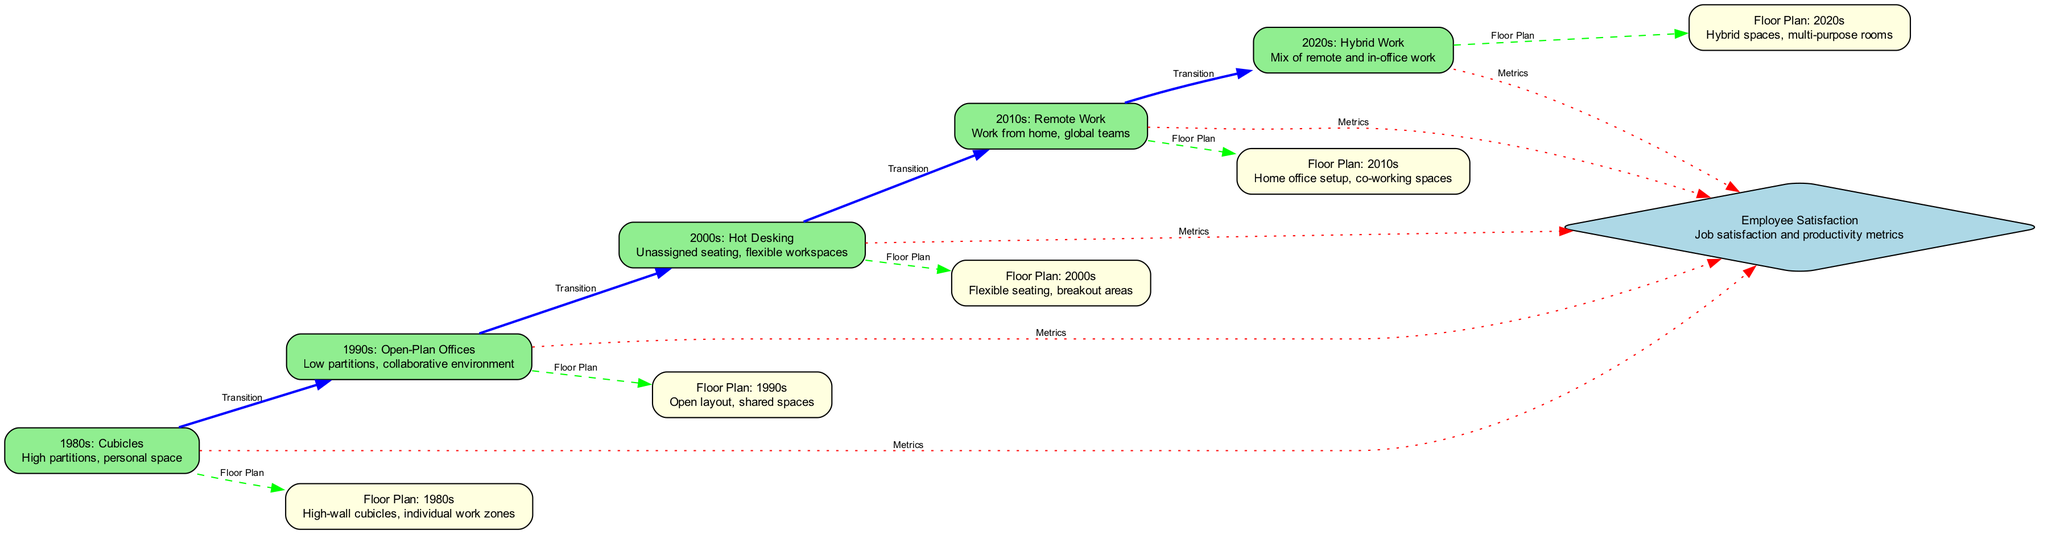What is the label of the node for the 1980s office design? The node for the 1980s office design is labeled "1980s: Cubicles". By examining the nodes in the diagram, I find the entry corresponding to "1980s" and read its associated label.
Answer: 1980s: Cubicles How many types of office designs are represented in the diagram? Counting the distinct office design nodes listed under 'nodes', I find five types: Cubicles, Open-Plan Offices, Hot Desking, Remote Work, and Hybrid Work.
Answer: Five What do the edges labeled "Transition" indicate? The edges labeled "Transition" connect various stages of office design evolution, showing the progression from one design to another. By examining the labels attached to each edge, I confirm they denote a transitional phase between different office designs.
Answer: Progression of office designs Which floor plan corresponds to the 2000s office design? The diagram indicates that the floor plan corresponding to the 2000s office design is labeled "Floor Plan: 2000s". I can directly relate nodes, specifically looking for the node under "2000s" and identifying its linked floor plan.
Answer: Floor Plan: 2000s What is the color of the nodes representing floor plans in the diagram? The nodes representing floor plans are colored light yellow. By reviewing the attributes of each node, I observe that all nodes containing "Floor Plan" explicitly have this color assigned.
Answer: Light yellow What is the relationship between "2010s: Remote Work" and "Employee Satisfaction"? The relationship is indicated by a dotted edge labeled "Metrics". This edge connects the node for "2010s: Remote Work" directly to "Employee Satisfaction", which implies a connection involving metrics related to job satisfaction during that period.
Answer: Metrics How does the design from the 1990s relate to employee satisfaction? The design from the 1990s is connected to employee satisfaction through an edge labeled "Metrics". I find the "1990s: Open-Plan Offices" node linked to the "Employee Satisfaction" node, indicating there's a measurement aspect relevant to this office style.
Answer: Metrics Which transition comes directly after Hot Desking? The transition directly after Hot Desking is to "2010s: Remote Work". By following the flow of edges in the diagram, I trace the connection leading from the node for "2000s: Hot Desking" to the next node.
Answer: 2010s: Remote Work What is the main feature of the 2020s office layout? The main feature of the 2020s office layout is a mix of remote and in-office work, as specified in the node description. I examine the node labeled "2020s: Hybrid Work" to extract this core attribute.
Answer: Mix of remote and in-office work 